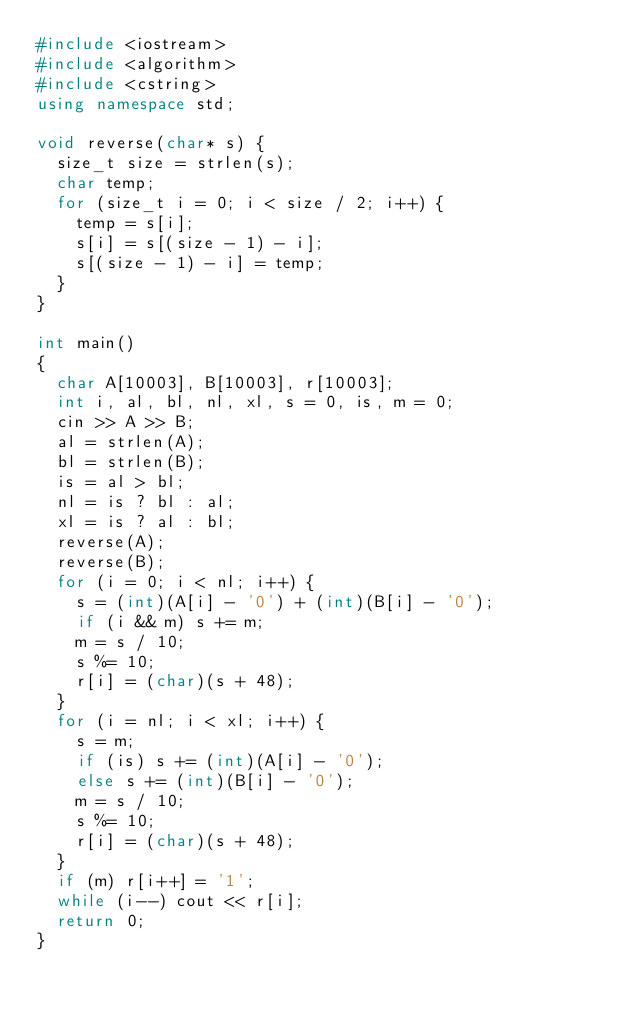Convert code to text. <code><loc_0><loc_0><loc_500><loc_500><_C++_>#include <iostream>
#include <algorithm>
#include <cstring>
using namespace std;

void reverse(char* s) {
  size_t size = strlen(s);
  char temp;
  for (size_t i = 0; i < size / 2; i++) {
    temp = s[i];
    s[i] = s[(size - 1) - i];
    s[(size - 1) - i] = temp;
  }
}

int main()
{
  char A[10003], B[10003], r[10003];
  int i, al, bl, nl, xl, s = 0, is, m = 0;
  cin >> A >> B;
  al = strlen(A);
  bl = strlen(B);
  is = al > bl;
  nl = is ? bl : al;
  xl = is ? al : bl;
  reverse(A);
  reverse(B);
  for (i = 0; i < nl; i++) {
    s = (int)(A[i] - '0') + (int)(B[i] - '0');
    if (i && m) s += m;
    m = s / 10;
    s %= 10;
    r[i] = (char)(s + 48);
  }
  for (i = nl; i < xl; i++) {
    s = m;
    if (is) s += (int)(A[i] - '0');
    else s += (int)(B[i] - '0');
    m = s / 10;
    s %= 10;
    r[i] = (char)(s + 48);
  }
  if (m) r[i++] = '1';
  while (i--) cout << r[i];
  return 0;
}
</code> 